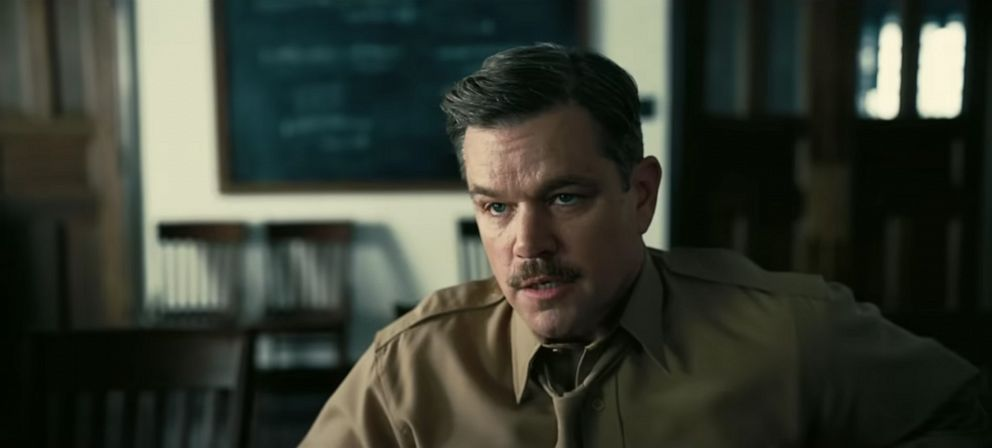What could be the possible context or story behind this scene? This image portrays an individual deeply immersed in thought, likely engaged in a scenario within an academic institution. He could be a professor or a researcher contemplating a complex scientific hypothesis or preparing for an important lecture. The blackboard's crowded equations suggest an intense focus on academic subjects, possibly an advanced topic in physics or mathematics. What's a creative scenario that could explain this image? Imagine a scenario where the man is a renowned scientist on the brink of a groundbreaking discovery. The equations on the blackboard are part of a theory that could change the course of human knowledge. He’s been at it for days, with minimal sleep, relentless in his pursuit of unlocking the universe's secrets. The serious expression reflects the weight of his task as he ponders the last crucial step to his revolutionary theory. Can you think of a completely imaginative and wild scenario for this image? In a world where time travel has become possible, the man is a time-travel mediator, responsible for ensuring that any changes made in the past do not drastically alter the present or future. The equations on the blackboard are not just mathematical formulas but temporal coordinates and probabilistic outcomes. He’s deciphering the complexities of a recent mission, ensuring that the minor tweak in history hasn’t set off a disastrous chain reaction. His serious look reflects the heavy responsibility of keeping the timelines intact. 